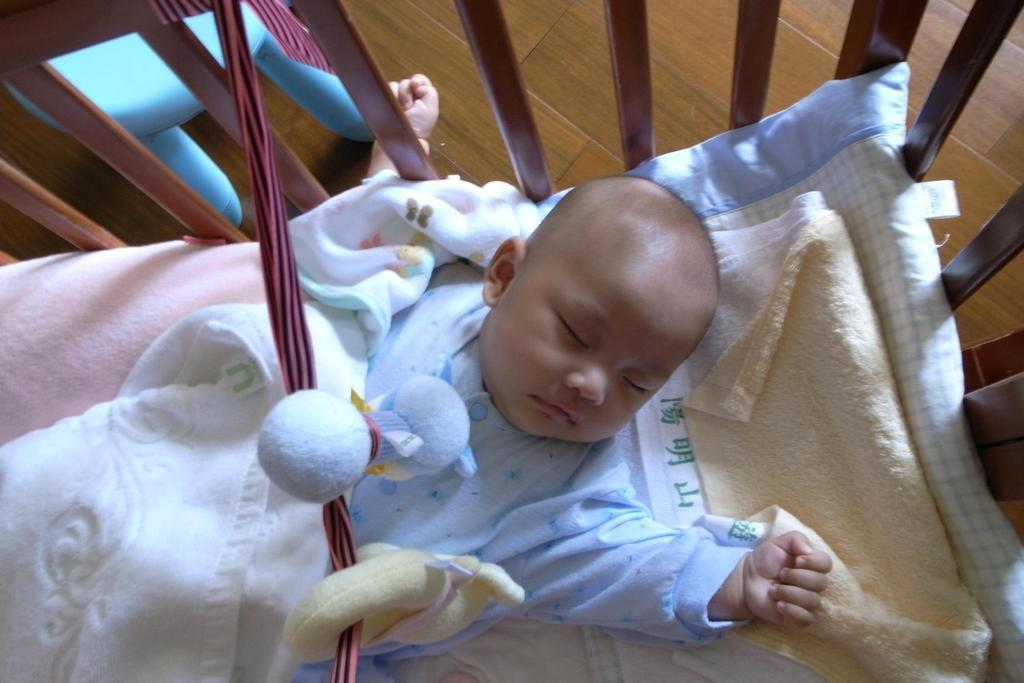What is the main subject of the image? The main subject of the image is a small kid. What is the kid doing in the image? The kid is sleeping. What is the kid wearing in the image? The kid is wearing a light blue color dress. What type of canvas is visible in the image? There is no canvas present in the image. What is the source of humor in the image? There is no humor depicted in the image; it simply shows a kid sleeping in a light blue color dress. 